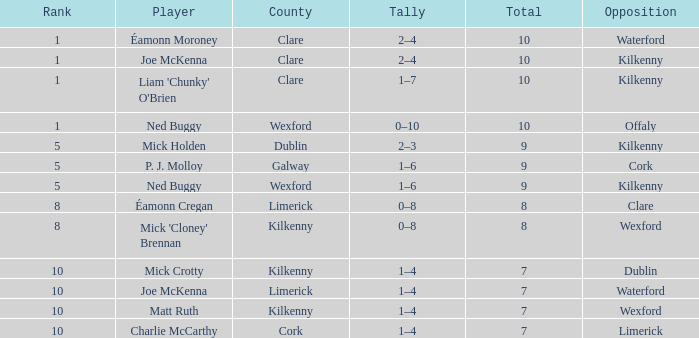What is the complete amount of galway county? 9.0. 